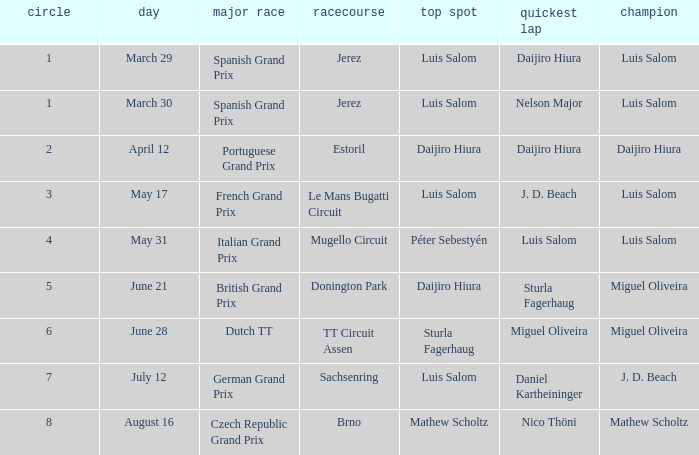Who had the fastest lap in the Dutch TT Grand Prix?  Miguel Oliveira. 